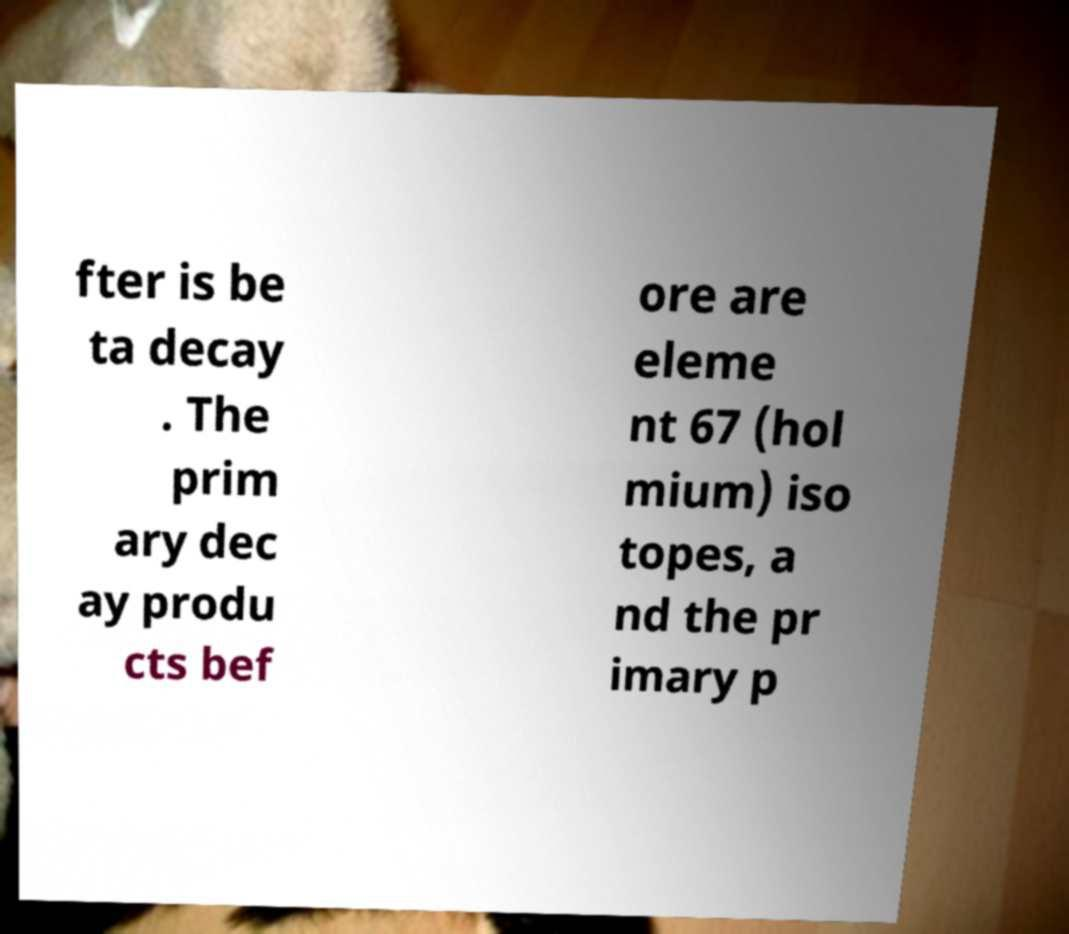I need the written content from this picture converted into text. Can you do that? fter is be ta decay . The prim ary dec ay produ cts bef ore are eleme nt 67 (hol mium) iso topes, a nd the pr imary p 